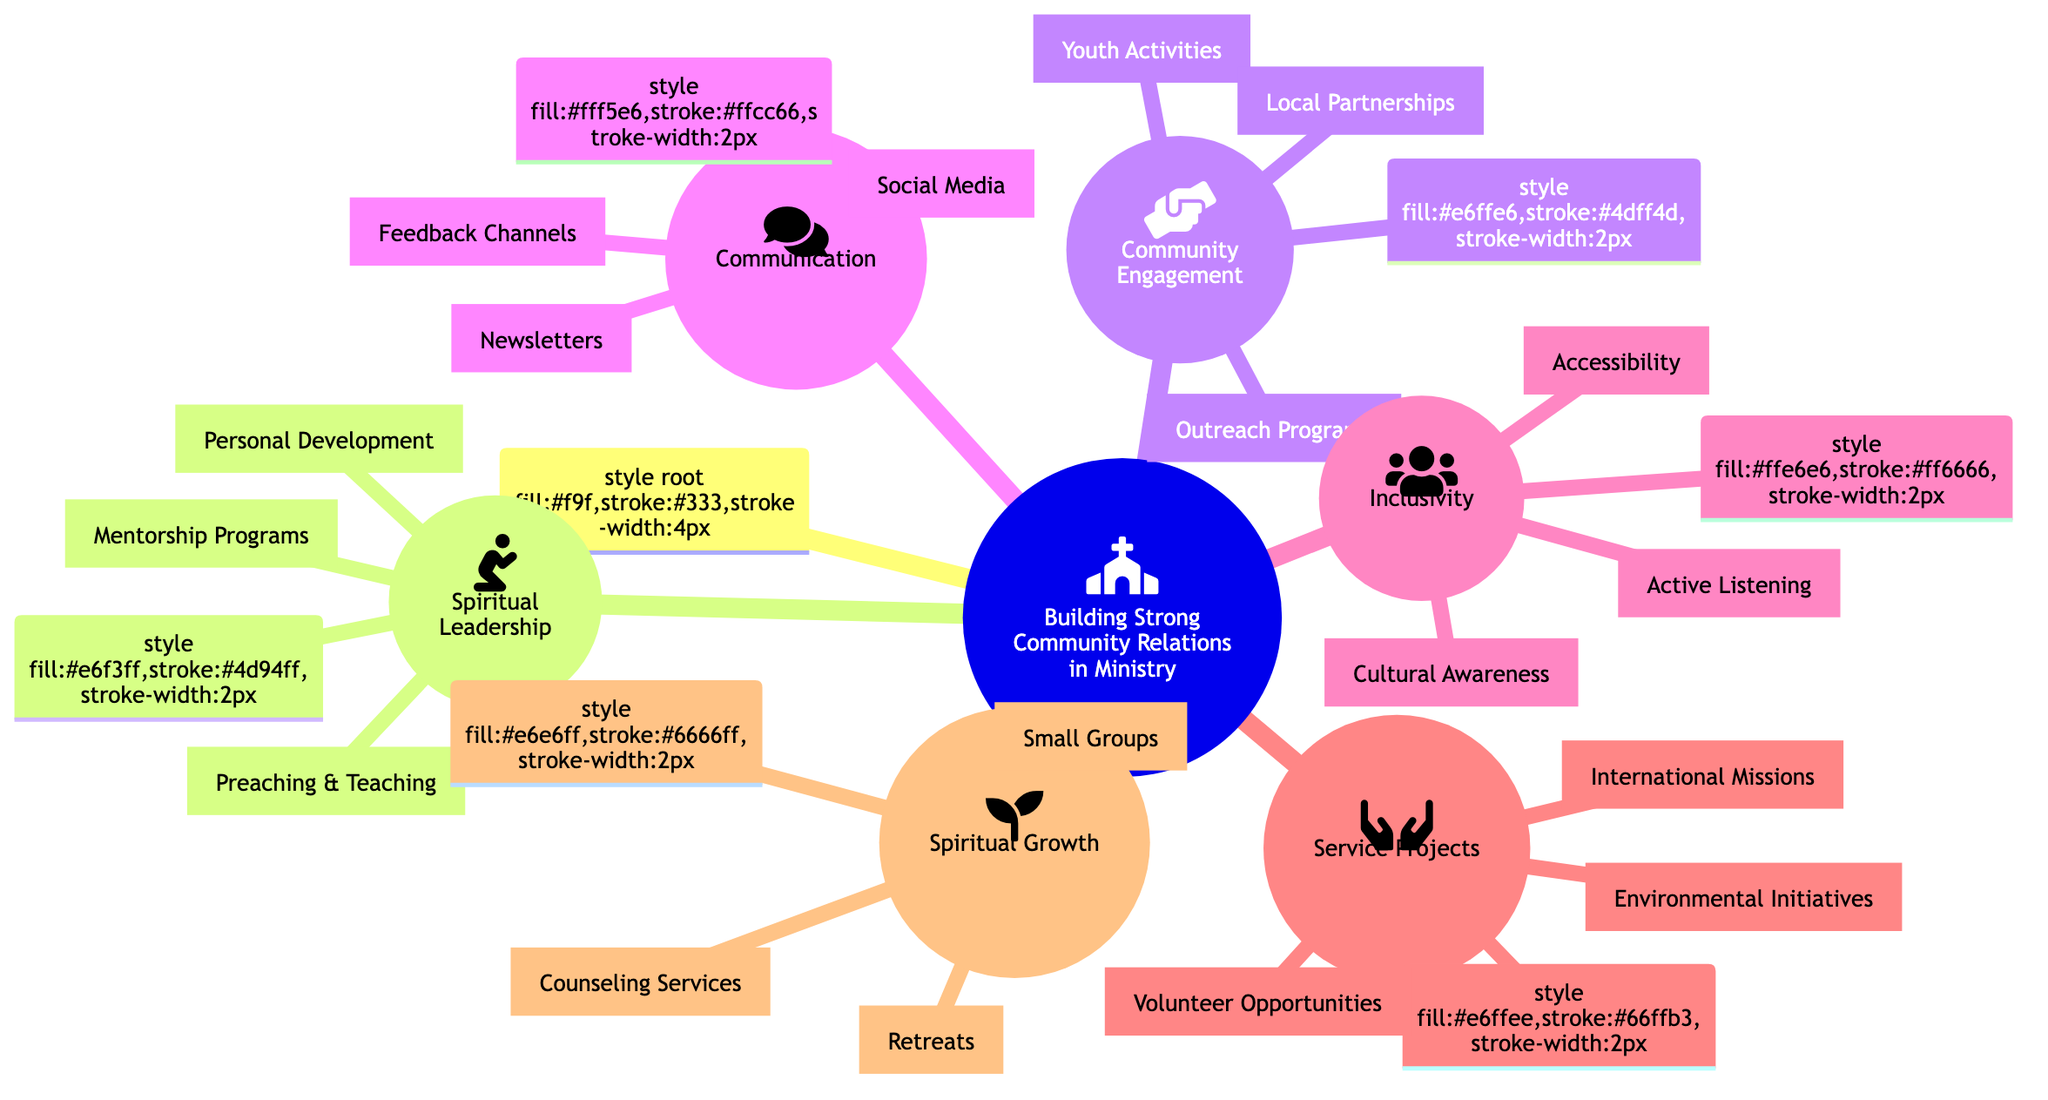What are the main categories in the mind map? The main categories in the mind map are identified as the top-level nodes branching from the root, which include Spiritual Leadership, Community Engagement, Communication, Inclusivity, Service Projects, and Spiritual Growth.
Answer: Spiritual Leadership, Community Engagement, Communication, Inclusivity, Service Projects, Spiritual Growth How many nodes are in the "Community Engagement" category? The "Community Engagement" category has three nodes listed under it, which are Outreach Programs, Youth Activities, and Local Partnerships.
Answer: 3 Which node is associated with cultural awareness? The node associated with cultural awareness is specifically labeled as Cultural Awareness under the Inclusivity category.
Answer: Cultural Awareness What kinds of programs fall under "Service Projects"? Under the "Service Projects" category, the programs listed are Volunteer Opportunities, Environmental Initiatives, and International Missions.
Answer: Volunteer Opportunities, Environmental Initiatives, International Missions From which category do we find "Feedback Channels"? The "Feedback Channels" node can be found under the Communication category, indicating its purpose in facilitating communication within the community.
Answer: Communication How does "Mentorship Programs" relate to "Personal Development"? Both "Mentorship Programs" and "Personal Development" are part of the same category, Spiritual Leadership, signifying their interconnected role in enhancing spiritual guidance and growth.
Answer: Spiritual Leadership What is the purpose of the "Youth Activities" node? The "Youth Activities" node aims to engage younger members of the community with Bible study groups, sports teams, and arts programs, indicating a focus on fostering youth participation.
Answer: Engage younger members Which initiatives are included in the "Environmental Initiatives" node? The "Environmental Initiatives" node encompasses community gardening and recycling programs, signifying a commitment to caring for the environment.
Answer: Community gardening, recycling programs What type of communication does "Social Media" represent? "Social Media" represents a type of communication that involves regular posts, live streams, and community groups, but serves primarily as a digital outreach tool.
Answer: Digital outreach tool 